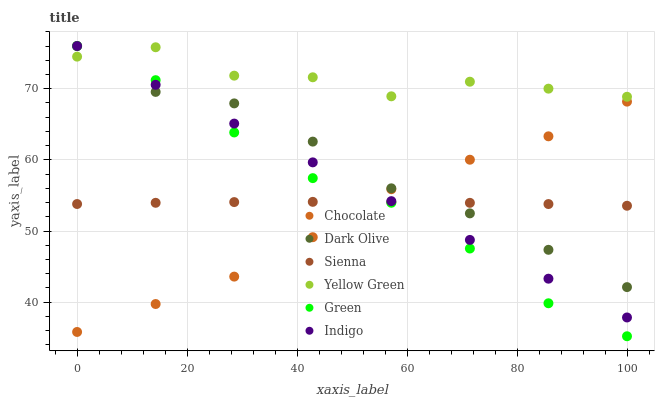Does Chocolate have the minimum area under the curve?
Answer yes or no. Yes. Does Yellow Green have the maximum area under the curve?
Answer yes or no. Yes. Does Dark Olive have the minimum area under the curve?
Answer yes or no. No. Does Dark Olive have the maximum area under the curve?
Answer yes or no. No. Is Indigo the smoothest?
Answer yes or no. Yes. Is Yellow Green the roughest?
Answer yes or no. Yes. Is Dark Olive the smoothest?
Answer yes or no. No. Is Dark Olive the roughest?
Answer yes or no. No. Does Green have the lowest value?
Answer yes or no. Yes. Does Dark Olive have the lowest value?
Answer yes or no. No. Does Green have the highest value?
Answer yes or no. Yes. Does Yellow Green have the highest value?
Answer yes or no. No. Is Chocolate less than Yellow Green?
Answer yes or no. Yes. Is Yellow Green greater than Sienna?
Answer yes or no. Yes. Does Indigo intersect Yellow Green?
Answer yes or no. Yes. Is Indigo less than Yellow Green?
Answer yes or no. No. Is Indigo greater than Yellow Green?
Answer yes or no. No. Does Chocolate intersect Yellow Green?
Answer yes or no. No. 